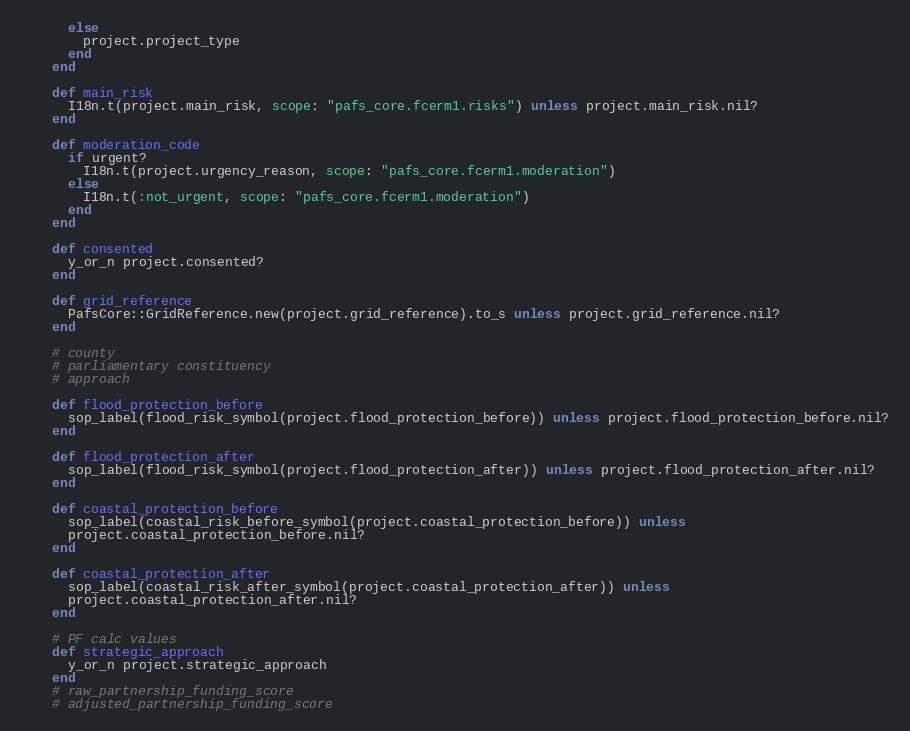Convert code to text. <code><loc_0><loc_0><loc_500><loc_500><_Ruby_>      else
        project.project_type
      end
    end

    def main_risk
      I18n.t(project.main_risk, scope: "pafs_core.fcerm1.risks") unless project.main_risk.nil?
    end

    def moderation_code
      if urgent?
        I18n.t(project.urgency_reason, scope: "pafs_core.fcerm1.moderation")
      else
        I18n.t(:not_urgent, scope: "pafs_core.fcerm1.moderation")
      end
    end

    def consented
      y_or_n project.consented?
    end

    def grid_reference
      PafsCore::GridReference.new(project.grid_reference).to_s unless project.grid_reference.nil?
    end

    # county
    # parliamentary constituency
    # approach

    def flood_protection_before
      sop_label(flood_risk_symbol(project.flood_protection_before)) unless project.flood_protection_before.nil?
    end

    def flood_protection_after
      sop_label(flood_risk_symbol(project.flood_protection_after)) unless project.flood_protection_after.nil?
    end

    def coastal_protection_before
      sop_label(coastal_risk_before_symbol(project.coastal_protection_before)) unless
      project.coastal_protection_before.nil?
    end

    def coastal_protection_after
      sop_label(coastal_risk_after_symbol(project.coastal_protection_after)) unless
      project.coastal_protection_after.nil?
    end

    # PF calc values
    def strategic_approach
      y_or_n project.strategic_approach
    end
    # raw_partnership_funding_score
    # adjusted_partnership_funding_score</code> 